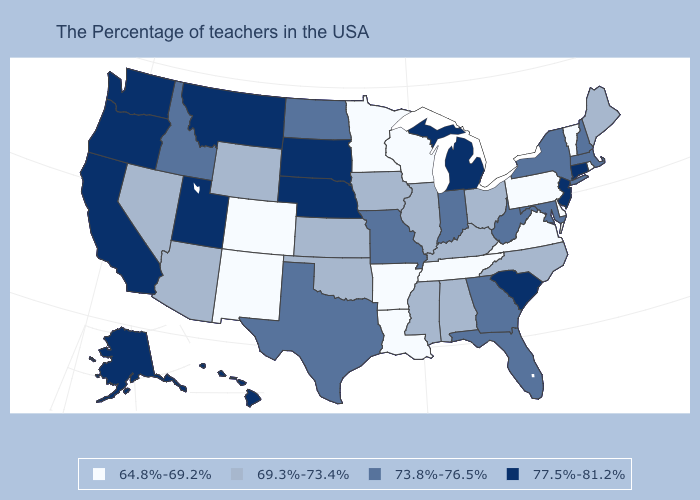What is the value of Georgia?
Short answer required. 73.8%-76.5%. What is the value of Ohio?
Write a very short answer. 69.3%-73.4%. What is the lowest value in the USA?
Concise answer only. 64.8%-69.2%. What is the value of Michigan?
Keep it brief. 77.5%-81.2%. How many symbols are there in the legend?
Short answer required. 4. What is the value of Montana?
Be succinct. 77.5%-81.2%. Among the states that border New Hampshire , does Maine have the lowest value?
Be succinct. No. Which states have the lowest value in the USA?
Quick response, please. Rhode Island, Vermont, Delaware, Pennsylvania, Virginia, Tennessee, Wisconsin, Louisiana, Arkansas, Minnesota, Colorado, New Mexico. What is the lowest value in the USA?
Be succinct. 64.8%-69.2%. Name the states that have a value in the range 69.3%-73.4%?
Quick response, please. Maine, North Carolina, Ohio, Kentucky, Alabama, Illinois, Mississippi, Iowa, Kansas, Oklahoma, Wyoming, Arizona, Nevada. Name the states that have a value in the range 73.8%-76.5%?
Give a very brief answer. Massachusetts, New Hampshire, New York, Maryland, West Virginia, Florida, Georgia, Indiana, Missouri, Texas, North Dakota, Idaho. Does the first symbol in the legend represent the smallest category?
Write a very short answer. Yes. Does Alaska have the lowest value in the USA?
Be succinct. No. Does California have the same value as Tennessee?
Give a very brief answer. No. Does Texas have the same value as New York?
Keep it brief. Yes. 